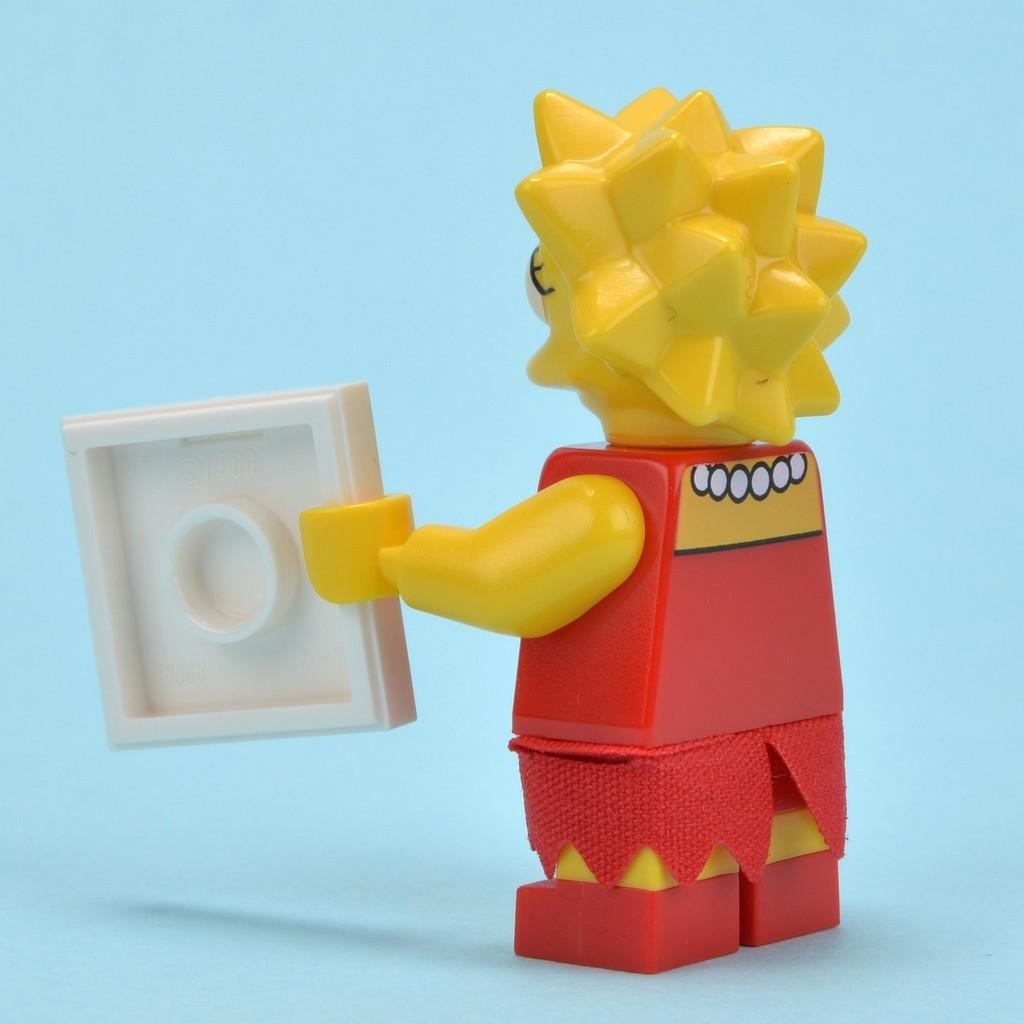What object can be seen in the image? There is a toy in the image. What is the toy holding in its hand? The toy is holding a block in its hand. What is the rate of the chess game being played in the image? There is no chess game present in the image, so it is not possible to determine the rate of any game being played. 